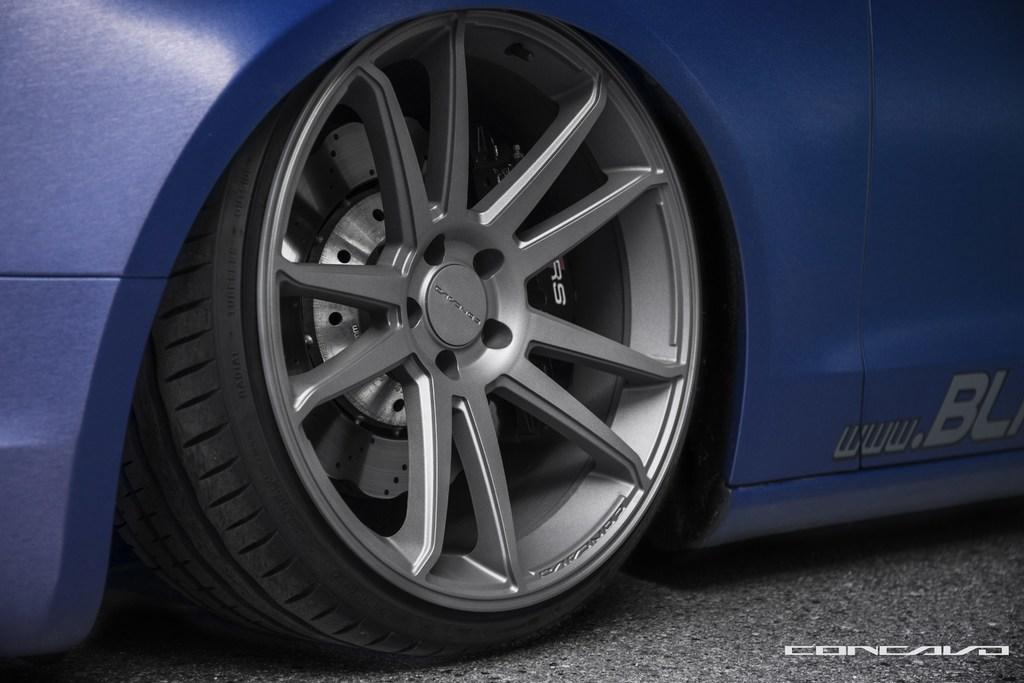What is the color of the car wheel visible in the image? The car wheel is blue. Where is the car wheel located in the image? The car wheel is on the road. What additional information can be found in the image? There is some text in the bottom right corner of the image. How many tomatoes are being used by the spy in the image? There is no spy or tomatoes present in the image. 